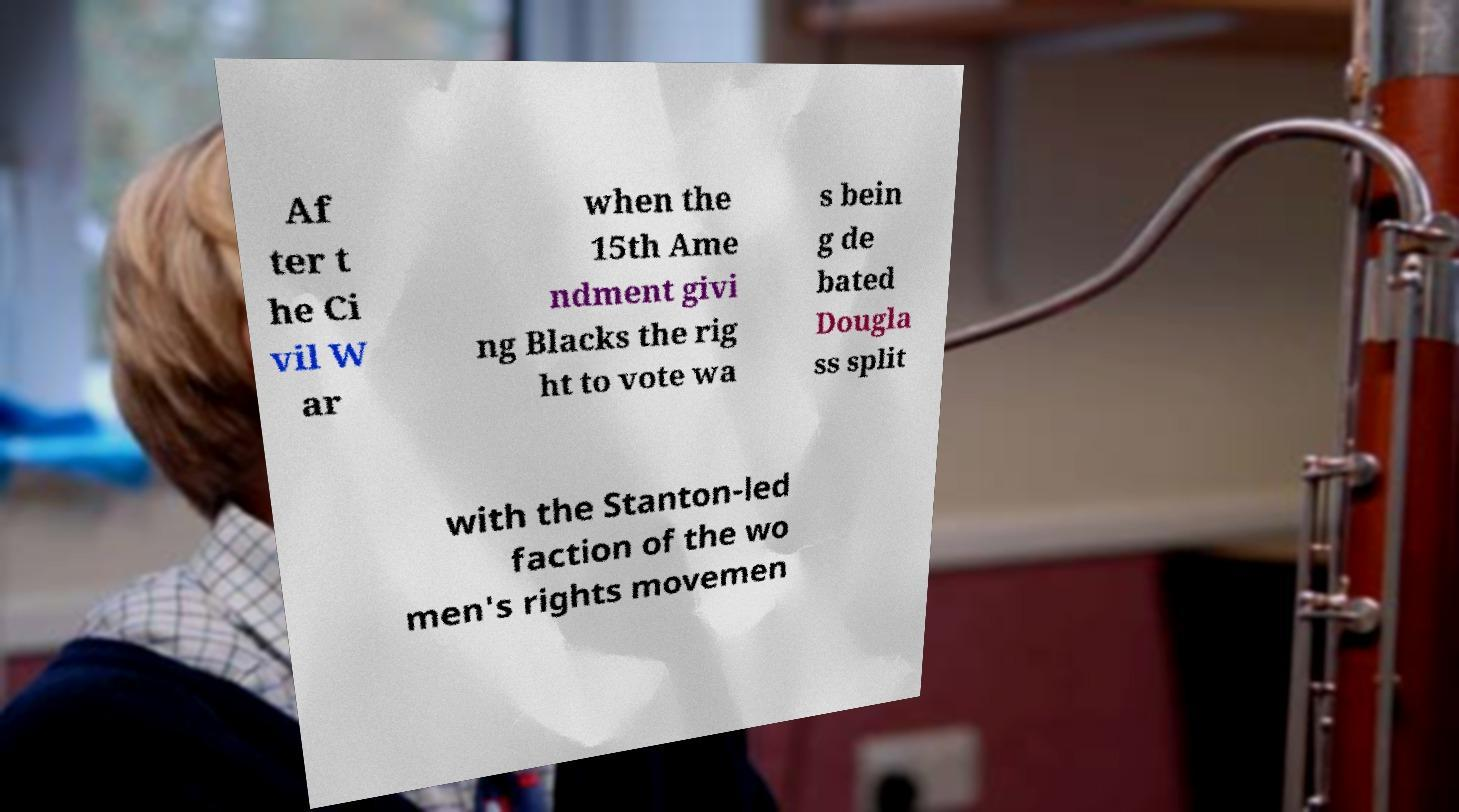Please identify and transcribe the text found in this image. Af ter t he Ci vil W ar when the 15th Ame ndment givi ng Blacks the rig ht to vote wa s bein g de bated Dougla ss split with the Stanton-led faction of the wo men's rights movemen 